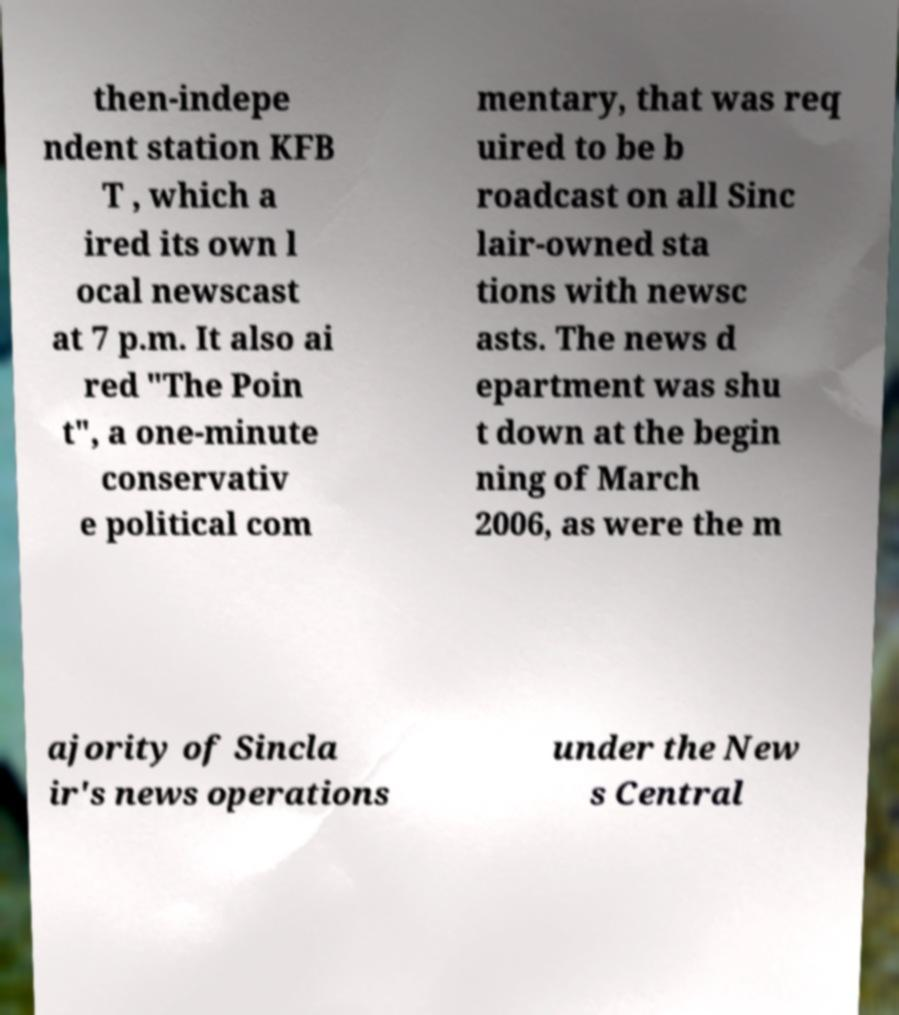Please read and relay the text visible in this image. What does it say? then-indepe ndent station KFB T , which a ired its own l ocal newscast at 7 p.m. It also ai red "The Poin t", a one-minute conservativ e political com mentary, that was req uired to be b roadcast on all Sinc lair-owned sta tions with newsc asts. The news d epartment was shu t down at the begin ning of March 2006, as were the m ajority of Sincla ir's news operations under the New s Central 